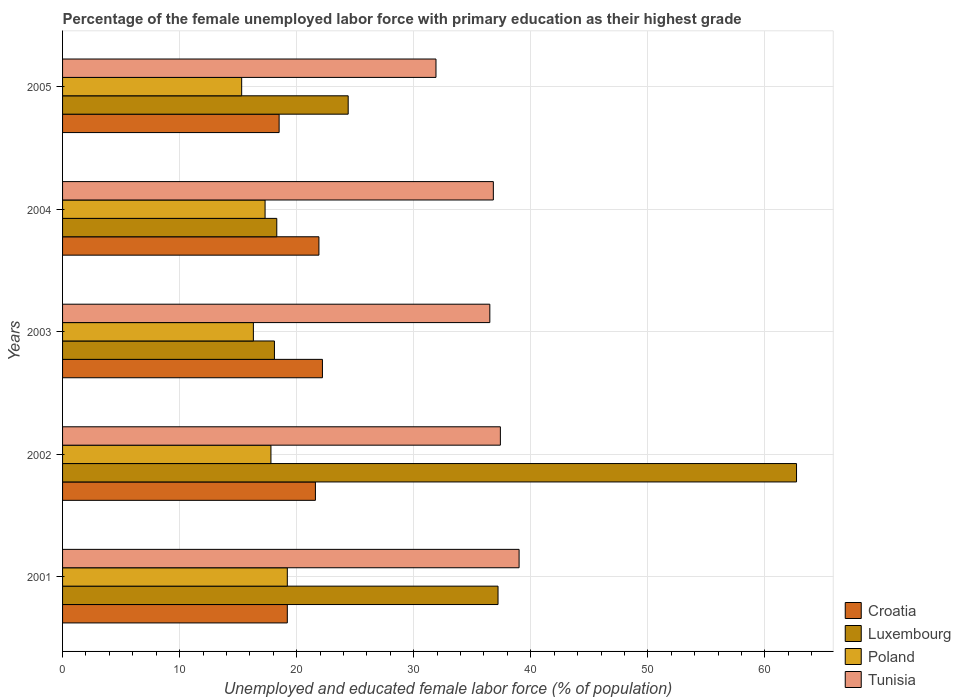How many different coloured bars are there?
Offer a very short reply. 4. How many groups of bars are there?
Offer a very short reply. 5. Are the number of bars on each tick of the Y-axis equal?
Provide a succinct answer. Yes. How many bars are there on the 2nd tick from the bottom?
Keep it short and to the point. 4. Across all years, what is the maximum percentage of the unemployed female labor force with primary education in Luxembourg?
Ensure brevity in your answer.  62.7. Across all years, what is the minimum percentage of the unemployed female labor force with primary education in Luxembourg?
Make the answer very short. 18.1. What is the total percentage of the unemployed female labor force with primary education in Tunisia in the graph?
Your response must be concise. 181.6. What is the difference between the percentage of the unemployed female labor force with primary education in Poland in 2002 and that in 2005?
Keep it short and to the point. 2.5. What is the difference between the percentage of the unemployed female labor force with primary education in Poland in 2005 and the percentage of the unemployed female labor force with primary education in Tunisia in 2003?
Offer a very short reply. -21.2. What is the average percentage of the unemployed female labor force with primary education in Poland per year?
Make the answer very short. 17.18. In the year 2003, what is the difference between the percentage of the unemployed female labor force with primary education in Tunisia and percentage of the unemployed female labor force with primary education in Poland?
Provide a short and direct response. 20.2. What is the ratio of the percentage of the unemployed female labor force with primary education in Luxembourg in 2002 to that in 2003?
Ensure brevity in your answer.  3.46. Is the difference between the percentage of the unemployed female labor force with primary education in Tunisia in 2001 and 2005 greater than the difference between the percentage of the unemployed female labor force with primary education in Poland in 2001 and 2005?
Make the answer very short. Yes. What is the difference between the highest and the second highest percentage of the unemployed female labor force with primary education in Croatia?
Your answer should be very brief. 0.3. What is the difference between the highest and the lowest percentage of the unemployed female labor force with primary education in Poland?
Ensure brevity in your answer.  3.9. Is the sum of the percentage of the unemployed female labor force with primary education in Tunisia in 2004 and 2005 greater than the maximum percentage of the unemployed female labor force with primary education in Croatia across all years?
Offer a very short reply. Yes. Is it the case that in every year, the sum of the percentage of the unemployed female labor force with primary education in Tunisia and percentage of the unemployed female labor force with primary education in Croatia is greater than the sum of percentage of the unemployed female labor force with primary education in Luxembourg and percentage of the unemployed female labor force with primary education in Poland?
Your response must be concise. Yes. What does the 2nd bar from the top in 2004 represents?
Your response must be concise. Poland. What is the difference between two consecutive major ticks on the X-axis?
Ensure brevity in your answer.  10. Are the values on the major ticks of X-axis written in scientific E-notation?
Keep it short and to the point. No. Does the graph contain any zero values?
Offer a terse response. No. Where does the legend appear in the graph?
Your answer should be compact. Bottom right. What is the title of the graph?
Your answer should be very brief. Percentage of the female unemployed labor force with primary education as their highest grade. What is the label or title of the X-axis?
Your response must be concise. Unemployed and educated female labor force (% of population). What is the label or title of the Y-axis?
Offer a very short reply. Years. What is the Unemployed and educated female labor force (% of population) in Croatia in 2001?
Offer a terse response. 19.2. What is the Unemployed and educated female labor force (% of population) of Luxembourg in 2001?
Give a very brief answer. 37.2. What is the Unemployed and educated female labor force (% of population) of Poland in 2001?
Ensure brevity in your answer.  19.2. What is the Unemployed and educated female labor force (% of population) in Tunisia in 2001?
Offer a terse response. 39. What is the Unemployed and educated female labor force (% of population) in Croatia in 2002?
Give a very brief answer. 21.6. What is the Unemployed and educated female labor force (% of population) of Luxembourg in 2002?
Ensure brevity in your answer.  62.7. What is the Unemployed and educated female labor force (% of population) of Poland in 2002?
Your answer should be very brief. 17.8. What is the Unemployed and educated female labor force (% of population) of Tunisia in 2002?
Your answer should be compact. 37.4. What is the Unemployed and educated female labor force (% of population) in Croatia in 2003?
Provide a succinct answer. 22.2. What is the Unemployed and educated female labor force (% of population) in Luxembourg in 2003?
Provide a short and direct response. 18.1. What is the Unemployed and educated female labor force (% of population) of Poland in 2003?
Keep it short and to the point. 16.3. What is the Unemployed and educated female labor force (% of population) of Tunisia in 2003?
Your response must be concise. 36.5. What is the Unemployed and educated female labor force (% of population) of Croatia in 2004?
Offer a very short reply. 21.9. What is the Unemployed and educated female labor force (% of population) of Luxembourg in 2004?
Your response must be concise. 18.3. What is the Unemployed and educated female labor force (% of population) of Poland in 2004?
Your answer should be very brief. 17.3. What is the Unemployed and educated female labor force (% of population) in Tunisia in 2004?
Make the answer very short. 36.8. What is the Unemployed and educated female labor force (% of population) of Croatia in 2005?
Your answer should be compact. 18.5. What is the Unemployed and educated female labor force (% of population) in Luxembourg in 2005?
Provide a short and direct response. 24.4. What is the Unemployed and educated female labor force (% of population) in Poland in 2005?
Keep it short and to the point. 15.3. What is the Unemployed and educated female labor force (% of population) of Tunisia in 2005?
Give a very brief answer. 31.9. Across all years, what is the maximum Unemployed and educated female labor force (% of population) in Croatia?
Make the answer very short. 22.2. Across all years, what is the maximum Unemployed and educated female labor force (% of population) in Luxembourg?
Make the answer very short. 62.7. Across all years, what is the maximum Unemployed and educated female labor force (% of population) of Poland?
Offer a terse response. 19.2. Across all years, what is the maximum Unemployed and educated female labor force (% of population) in Tunisia?
Offer a very short reply. 39. Across all years, what is the minimum Unemployed and educated female labor force (% of population) of Croatia?
Offer a very short reply. 18.5. Across all years, what is the minimum Unemployed and educated female labor force (% of population) of Luxembourg?
Your answer should be compact. 18.1. Across all years, what is the minimum Unemployed and educated female labor force (% of population) in Poland?
Your answer should be very brief. 15.3. Across all years, what is the minimum Unemployed and educated female labor force (% of population) in Tunisia?
Make the answer very short. 31.9. What is the total Unemployed and educated female labor force (% of population) of Croatia in the graph?
Your answer should be compact. 103.4. What is the total Unemployed and educated female labor force (% of population) in Luxembourg in the graph?
Your answer should be very brief. 160.7. What is the total Unemployed and educated female labor force (% of population) in Poland in the graph?
Your answer should be very brief. 85.9. What is the total Unemployed and educated female labor force (% of population) in Tunisia in the graph?
Your response must be concise. 181.6. What is the difference between the Unemployed and educated female labor force (% of population) of Croatia in 2001 and that in 2002?
Ensure brevity in your answer.  -2.4. What is the difference between the Unemployed and educated female labor force (% of population) of Luxembourg in 2001 and that in 2002?
Your answer should be very brief. -25.5. What is the difference between the Unemployed and educated female labor force (% of population) of Poland in 2001 and that in 2002?
Make the answer very short. 1.4. What is the difference between the Unemployed and educated female labor force (% of population) of Croatia in 2001 and that in 2003?
Ensure brevity in your answer.  -3. What is the difference between the Unemployed and educated female labor force (% of population) in Poland in 2001 and that in 2003?
Provide a succinct answer. 2.9. What is the difference between the Unemployed and educated female labor force (% of population) in Croatia in 2001 and that in 2004?
Your answer should be compact. -2.7. What is the difference between the Unemployed and educated female labor force (% of population) of Luxembourg in 2001 and that in 2004?
Make the answer very short. 18.9. What is the difference between the Unemployed and educated female labor force (% of population) in Luxembourg in 2001 and that in 2005?
Give a very brief answer. 12.8. What is the difference between the Unemployed and educated female labor force (% of population) of Croatia in 2002 and that in 2003?
Offer a terse response. -0.6. What is the difference between the Unemployed and educated female labor force (% of population) in Luxembourg in 2002 and that in 2003?
Make the answer very short. 44.6. What is the difference between the Unemployed and educated female labor force (% of population) in Tunisia in 2002 and that in 2003?
Provide a short and direct response. 0.9. What is the difference between the Unemployed and educated female labor force (% of population) of Croatia in 2002 and that in 2004?
Make the answer very short. -0.3. What is the difference between the Unemployed and educated female labor force (% of population) in Luxembourg in 2002 and that in 2004?
Make the answer very short. 44.4. What is the difference between the Unemployed and educated female labor force (% of population) in Tunisia in 2002 and that in 2004?
Your answer should be very brief. 0.6. What is the difference between the Unemployed and educated female labor force (% of population) in Luxembourg in 2002 and that in 2005?
Keep it short and to the point. 38.3. What is the difference between the Unemployed and educated female labor force (% of population) in Poland in 2002 and that in 2005?
Your answer should be compact. 2.5. What is the difference between the Unemployed and educated female labor force (% of population) in Tunisia in 2002 and that in 2005?
Offer a very short reply. 5.5. What is the difference between the Unemployed and educated female labor force (% of population) in Croatia in 2003 and that in 2004?
Your answer should be very brief. 0.3. What is the difference between the Unemployed and educated female labor force (% of population) in Luxembourg in 2003 and that in 2004?
Provide a short and direct response. -0.2. What is the difference between the Unemployed and educated female labor force (% of population) of Tunisia in 2003 and that in 2004?
Give a very brief answer. -0.3. What is the difference between the Unemployed and educated female labor force (% of population) of Croatia in 2003 and that in 2005?
Your response must be concise. 3.7. What is the difference between the Unemployed and educated female labor force (% of population) of Luxembourg in 2003 and that in 2005?
Your answer should be compact. -6.3. What is the difference between the Unemployed and educated female labor force (% of population) in Poland in 2003 and that in 2005?
Provide a succinct answer. 1. What is the difference between the Unemployed and educated female labor force (% of population) of Luxembourg in 2004 and that in 2005?
Your response must be concise. -6.1. What is the difference between the Unemployed and educated female labor force (% of population) of Poland in 2004 and that in 2005?
Make the answer very short. 2. What is the difference between the Unemployed and educated female labor force (% of population) of Tunisia in 2004 and that in 2005?
Make the answer very short. 4.9. What is the difference between the Unemployed and educated female labor force (% of population) of Croatia in 2001 and the Unemployed and educated female labor force (% of population) of Luxembourg in 2002?
Keep it short and to the point. -43.5. What is the difference between the Unemployed and educated female labor force (% of population) in Croatia in 2001 and the Unemployed and educated female labor force (% of population) in Poland in 2002?
Your answer should be compact. 1.4. What is the difference between the Unemployed and educated female labor force (% of population) in Croatia in 2001 and the Unemployed and educated female labor force (% of population) in Tunisia in 2002?
Offer a terse response. -18.2. What is the difference between the Unemployed and educated female labor force (% of population) of Poland in 2001 and the Unemployed and educated female labor force (% of population) of Tunisia in 2002?
Make the answer very short. -18.2. What is the difference between the Unemployed and educated female labor force (% of population) in Croatia in 2001 and the Unemployed and educated female labor force (% of population) in Luxembourg in 2003?
Your answer should be very brief. 1.1. What is the difference between the Unemployed and educated female labor force (% of population) of Croatia in 2001 and the Unemployed and educated female labor force (% of population) of Tunisia in 2003?
Your response must be concise. -17.3. What is the difference between the Unemployed and educated female labor force (% of population) in Luxembourg in 2001 and the Unemployed and educated female labor force (% of population) in Poland in 2003?
Offer a terse response. 20.9. What is the difference between the Unemployed and educated female labor force (% of population) of Luxembourg in 2001 and the Unemployed and educated female labor force (% of population) of Tunisia in 2003?
Your answer should be very brief. 0.7. What is the difference between the Unemployed and educated female labor force (% of population) of Poland in 2001 and the Unemployed and educated female labor force (% of population) of Tunisia in 2003?
Your response must be concise. -17.3. What is the difference between the Unemployed and educated female labor force (% of population) of Croatia in 2001 and the Unemployed and educated female labor force (% of population) of Poland in 2004?
Offer a terse response. 1.9. What is the difference between the Unemployed and educated female labor force (% of population) of Croatia in 2001 and the Unemployed and educated female labor force (% of population) of Tunisia in 2004?
Give a very brief answer. -17.6. What is the difference between the Unemployed and educated female labor force (% of population) in Luxembourg in 2001 and the Unemployed and educated female labor force (% of population) in Poland in 2004?
Keep it short and to the point. 19.9. What is the difference between the Unemployed and educated female labor force (% of population) in Poland in 2001 and the Unemployed and educated female labor force (% of population) in Tunisia in 2004?
Your answer should be compact. -17.6. What is the difference between the Unemployed and educated female labor force (% of population) of Croatia in 2001 and the Unemployed and educated female labor force (% of population) of Luxembourg in 2005?
Provide a succinct answer. -5.2. What is the difference between the Unemployed and educated female labor force (% of population) in Luxembourg in 2001 and the Unemployed and educated female labor force (% of population) in Poland in 2005?
Provide a succinct answer. 21.9. What is the difference between the Unemployed and educated female labor force (% of population) in Luxembourg in 2001 and the Unemployed and educated female labor force (% of population) in Tunisia in 2005?
Keep it short and to the point. 5.3. What is the difference between the Unemployed and educated female labor force (% of population) of Croatia in 2002 and the Unemployed and educated female labor force (% of population) of Tunisia in 2003?
Provide a short and direct response. -14.9. What is the difference between the Unemployed and educated female labor force (% of population) of Luxembourg in 2002 and the Unemployed and educated female labor force (% of population) of Poland in 2003?
Provide a succinct answer. 46.4. What is the difference between the Unemployed and educated female labor force (% of population) in Luxembourg in 2002 and the Unemployed and educated female labor force (% of population) in Tunisia in 2003?
Your response must be concise. 26.2. What is the difference between the Unemployed and educated female labor force (% of population) in Poland in 2002 and the Unemployed and educated female labor force (% of population) in Tunisia in 2003?
Provide a succinct answer. -18.7. What is the difference between the Unemployed and educated female labor force (% of population) of Croatia in 2002 and the Unemployed and educated female labor force (% of population) of Luxembourg in 2004?
Make the answer very short. 3.3. What is the difference between the Unemployed and educated female labor force (% of population) in Croatia in 2002 and the Unemployed and educated female labor force (% of population) in Tunisia in 2004?
Your answer should be compact. -15.2. What is the difference between the Unemployed and educated female labor force (% of population) of Luxembourg in 2002 and the Unemployed and educated female labor force (% of population) of Poland in 2004?
Make the answer very short. 45.4. What is the difference between the Unemployed and educated female labor force (% of population) in Luxembourg in 2002 and the Unemployed and educated female labor force (% of population) in Tunisia in 2004?
Provide a succinct answer. 25.9. What is the difference between the Unemployed and educated female labor force (% of population) in Poland in 2002 and the Unemployed and educated female labor force (% of population) in Tunisia in 2004?
Make the answer very short. -19. What is the difference between the Unemployed and educated female labor force (% of population) of Croatia in 2002 and the Unemployed and educated female labor force (% of population) of Tunisia in 2005?
Give a very brief answer. -10.3. What is the difference between the Unemployed and educated female labor force (% of population) of Luxembourg in 2002 and the Unemployed and educated female labor force (% of population) of Poland in 2005?
Your answer should be compact. 47.4. What is the difference between the Unemployed and educated female labor force (% of population) in Luxembourg in 2002 and the Unemployed and educated female labor force (% of population) in Tunisia in 2005?
Offer a terse response. 30.8. What is the difference between the Unemployed and educated female labor force (% of population) of Poland in 2002 and the Unemployed and educated female labor force (% of population) of Tunisia in 2005?
Make the answer very short. -14.1. What is the difference between the Unemployed and educated female labor force (% of population) in Croatia in 2003 and the Unemployed and educated female labor force (% of population) in Tunisia in 2004?
Provide a succinct answer. -14.6. What is the difference between the Unemployed and educated female labor force (% of population) in Luxembourg in 2003 and the Unemployed and educated female labor force (% of population) in Tunisia in 2004?
Provide a short and direct response. -18.7. What is the difference between the Unemployed and educated female labor force (% of population) of Poland in 2003 and the Unemployed and educated female labor force (% of population) of Tunisia in 2004?
Keep it short and to the point. -20.5. What is the difference between the Unemployed and educated female labor force (% of population) in Croatia in 2003 and the Unemployed and educated female labor force (% of population) in Tunisia in 2005?
Your answer should be compact. -9.7. What is the difference between the Unemployed and educated female labor force (% of population) of Poland in 2003 and the Unemployed and educated female labor force (% of population) of Tunisia in 2005?
Your response must be concise. -15.6. What is the difference between the Unemployed and educated female labor force (% of population) of Croatia in 2004 and the Unemployed and educated female labor force (% of population) of Tunisia in 2005?
Your answer should be very brief. -10. What is the difference between the Unemployed and educated female labor force (% of population) of Luxembourg in 2004 and the Unemployed and educated female labor force (% of population) of Poland in 2005?
Your response must be concise. 3. What is the difference between the Unemployed and educated female labor force (% of population) in Poland in 2004 and the Unemployed and educated female labor force (% of population) in Tunisia in 2005?
Your answer should be very brief. -14.6. What is the average Unemployed and educated female labor force (% of population) of Croatia per year?
Keep it short and to the point. 20.68. What is the average Unemployed and educated female labor force (% of population) of Luxembourg per year?
Ensure brevity in your answer.  32.14. What is the average Unemployed and educated female labor force (% of population) in Poland per year?
Make the answer very short. 17.18. What is the average Unemployed and educated female labor force (% of population) in Tunisia per year?
Keep it short and to the point. 36.32. In the year 2001, what is the difference between the Unemployed and educated female labor force (% of population) in Croatia and Unemployed and educated female labor force (% of population) in Luxembourg?
Your answer should be compact. -18. In the year 2001, what is the difference between the Unemployed and educated female labor force (% of population) of Croatia and Unemployed and educated female labor force (% of population) of Poland?
Offer a very short reply. 0. In the year 2001, what is the difference between the Unemployed and educated female labor force (% of population) in Croatia and Unemployed and educated female labor force (% of population) in Tunisia?
Give a very brief answer. -19.8. In the year 2001, what is the difference between the Unemployed and educated female labor force (% of population) in Poland and Unemployed and educated female labor force (% of population) in Tunisia?
Provide a succinct answer. -19.8. In the year 2002, what is the difference between the Unemployed and educated female labor force (% of population) in Croatia and Unemployed and educated female labor force (% of population) in Luxembourg?
Offer a terse response. -41.1. In the year 2002, what is the difference between the Unemployed and educated female labor force (% of population) of Croatia and Unemployed and educated female labor force (% of population) of Tunisia?
Make the answer very short. -15.8. In the year 2002, what is the difference between the Unemployed and educated female labor force (% of population) of Luxembourg and Unemployed and educated female labor force (% of population) of Poland?
Offer a very short reply. 44.9. In the year 2002, what is the difference between the Unemployed and educated female labor force (% of population) of Luxembourg and Unemployed and educated female labor force (% of population) of Tunisia?
Your answer should be compact. 25.3. In the year 2002, what is the difference between the Unemployed and educated female labor force (% of population) of Poland and Unemployed and educated female labor force (% of population) of Tunisia?
Provide a succinct answer. -19.6. In the year 2003, what is the difference between the Unemployed and educated female labor force (% of population) in Croatia and Unemployed and educated female labor force (% of population) in Luxembourg?
Give a very brief answer. 4.1. In the year 2003, what is the difference between the Unemployed and educated female labor force (% of population) of Croatia and Unemployed and educated female labor force (% of population) of Tunisia?
Offer a very short reply. -14.3. In the year 2003, what is the difference between the Unemployed and educated female labor force (% of population) in Luxembourg and Unemployed and educated female labor force (% of population) in Tunisia?
Provide a short and direct response. -18.4. In the year 2003, what is the difference between the Unemployed and educated female labor force (% of population) of Poland and Unemployed and educated female labor force (% of population) of Tunisia?
Your answer should be very brief. -20.2. In the year 2004, what is the difference between the Unemployed and educated female labor force (% of population) in Croatia and Unemployed and educated female labor force (% of population) in Luxembourg?
Offer a terse response. 3.6. In the year 2004, what is the difference between the Unemployed and educated female labor force (% of population) of Croatia and Unemployed and educated female labor force (% of population) of Poland?
Give a very brief answer. 4.6. In the year 2004, what is the difference between the Unemployed and educated female labor force (% of population) in Croatia and Unemployed and educated female labor force (% of population) in Tunisia?
Offer a very short reply. -14.9. In the year 2004, what is the difference between the Unemployed and educated female labor force (% of population) of Luxembourg and Unemployed and educated female labor force (% of population) of Poland?
Your response must be concise. 1. In the year 2004, what is the difference between the Unemployed and educated female labor force (% of population) of Luxembourg and Unemployed and educated female labor force (% of population) of Tunisia?
Your answer should be very brief. -18.5. In the year 2004, what is the difference between the Unemployed and educated female labor force (% of population) in Poland and Unemployed and educated female labor force (% of population) in Tunisia?
Give a very brief answer. -19.5. In the year 2005, what is the difference between the Unemployed and educated female labor force (% of population) of Luxembourg and Unemployed and educated female labor force (% of population) of Tunisia?
Provide a short and direct response. -7.5. In the year 2005, what is the difference between the Unemployed and educated female labor force (% of population) in Poland and Unemployed and educated female labor force (% of population) in Tunisia?
Make the answer very short. -16.6. What is the ratio of the Unemployed and educated female labor force (% of population) of Luxembourg in 2001 to that in 2002?
Provide a short and direct response. 0.59. What is the ratio of the Unemployed and educated female labor force (% of population) in Poland in 2001 to that in 2002?
Offer a very short reply. 1.08. What is the ratio of the Unemployed and educated female labor force (% of population) of Tunisia in 2001 to that in 2002?
Make the answer very short. 1.04. What is the ratio of the Unemployed and educated female labor force (% of population) of Croatia in 2001 to that in 2003?
Offer a terse response. 0.86. What is the ratio of the Unemployed and educated female labor force (% of population) of Luxembourg in 2001 to that in 2003?
Keep it short and to the point. 2.06. What is the ratio of the Unemployed and educated female labor force (% of population) of Poland in 2001 to that in 2003?
Ensure brevity in your answer.  1.18. What is the ratio of the Unemployed and educated female labor force (% of population) of Tunisia in 2001 to that in 2003?
Give a very brief answer. 1.07. What is the ratio of the Unemployed and educated female labor force (% of population) in Croatia in 2001 to that in 2004?
Provide a short and direct response. 0.88. What is the ratio of the Unemployed and educated female labor force (% of population) of Luxembourg in 2001 to that in 2004?
Make the answer very short. 2.03. What is the ratio of the Unemployed and educated female labor force (% of population) of Poland in 2001 to that in 2004?
Your answer should be very brief. 1.11. What is the ratio of the Unemployed and educated female labor force (% of population) in Tunisia in 2001 to that in 2004?
Provide a short and direct response. 1.06. What is the ratio of the Unemployed and educated female labor force (% of population) of Croatia in 2001 to that in 2005?
Provide a short and direct response. 1.04. What is the ratio of the Unemployed and educated female labor force (% of population) in Luxembourg in 2001 to that in 2005?
Make the answer very short. 1.52. What is the ratio of the Unemployed and educated female labor force (% of population) in Poland in 2001 to that in 2005?
Provide a succinct answer. 1.25. What is the ratio of the Unemployed and educated female labor force (% of population) of Tunisia in 2001 to that in 2005?
Give a very brief answer. 1.22. What is the ratio of the Unemployed and educated female labor force (% of population) in Croatia in 2002 to that in 2003?
Provide a succinct answer. 0.97. What is the ratio of the Unemployed and educated female labor force (% of population) in Luxembourg in 2002 to that in 2003?
Your answer should be very brief. 3.46. What is the ratio of the Unemployed and educated female labor force (% of population) of Poland in 2002 to that in 2003?
Make the answer very short. 1.09. What is the ratio of the Unemployed and educated female labor force (% of population) in Tunisia in 2002 to that in 2003?
Ensure brevity in your answer.  1.02. What is the ratio of the Unemployed and educated female labor force (% of population) of Croatia in 2002 to that in 2004?
Make the answer very short. 0.99. What is the ratio of the Unemployed and educated female labor force (% of population) of Luxembourg in 2002 to that in 2004?
Ensure brevity in your answer.  3.43. What is the ratio of the Unemployed and educated female labor force (% of population) in Poland in 2002 to that in 2004?
Your answer should be very brief. 1.03. What is the ratio of the Unemployed and educated female labor force (% of population) of Tunisia in 2002 to that in 2004?
Your response must be concise. 1.02. What is the ratio of the Unemployed and educated female labor force (% of population) of Croatia in 2002 to that in 2005?
Make the answer very short. 1.17. What is the ratio of the Unemployed and educated female labor force (% of population) in Luxembourg in 2002 to that in 2005?
Offer a terse response. 2.57. What is the ratio of the Unemployed and educated female labor force (% of population) of Poland in 2002 to that in 2005?
Give a very brief answer. 1.16. What is the ratio of the Unemployed and educated female labor force (% of population) of Tunisia in 2002 to that in 2005?
Your response must be concise. 1.17. What is the ratio of the Unemployed and educated female labor force (% of population) of Croatia in 2003 to that in 2004?
Offer a very short reply. 1.01. What is the ratio of the Unemployed and educated female labor force (% of population) of Luxembourg in 2003 to that in 2004?
Provide a succinct answer. 0.99. What is the ratio of the Unemployed and educated female labor force (% of population) in Poland in 2003 to that in 2004?
Give a very brief answer. 0.94. What is the ratio of the Unemployed and educated female labor force (% of population) of Luxembourg in 2003 to that in 2005?
Provide a succinct answer. 0.74. What is the ratio of the Unemployed and educated female labor force (% of population) of Poland in 2003 to that in 2005?
Offer a terse response. 1.07. What is the ratio of the Unemployed and educated female labor force (% of population) in Tunisia in 2003 to that in 2005?
Your answer should be very brief. 1.14. What is the ratio of the Unemployed and educated female labor force (% of population) of Croatia in 2004 to that in 2005?
Provide a succinct answer. 1.18. What is the ratio of the Unemployed and educated female labor force (% of population) in Poland in 2004 to that in 2005?
Ensure brevity in your answer.  1.13. What is the ratio of the Unemployed and educated female labor force (% of population) of Tunisia in 2004 to that in 2005?
Provide a succinct answer. 1.15. What is the difference between the highest and the second highest Unemployed and educated female labor force (% of population) in Croatia?
Your answer should be compact. 0.3. What is the difference between the highest and the second highest Unemployed and educated female labor force (% of population) of Tunisia?
Your answer should be very brief. 1.6. What is the difference between the highest and the lowest Unemployed and educated female labor force (% of population) of Croatia?
Offer a very short reply. 3.7. What is the difference between the highest and the lowest Unemployed and educated female labor force (% of population) in Luxembourg?
Give a very brief answer. 44.6. What is the difference between the highest and the lowest Unemployed and educated female labor force (% of population) in Tunisia?
Offer a terse response. 7.1. 